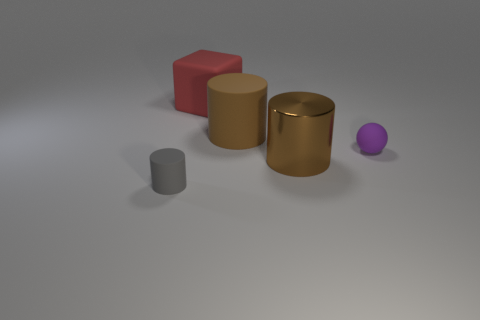What is the purple ball made of?
Provide a succinct answer. Rubber. There is a brown cylinder that is in front of the rubber ball; is it the same size as the brown matte cylinder?
Provide a short and direct response. Yes. Is there any other thing that is the same size as the purple sphere?
Ensure brevity in your answer.  Yes. What is the size of the brown rubber thing that is the same shape as the brown metallic object?
Offer a very short reply. Large. Is the number of big things that are to the right of the large red block the same as the number of small rubber things in front of the big shiny cylinder?
Ensure brevity in your answer.  No. How big is the gray thing in front of the brown matte thing?
Give a very brief answer. Small. Does the large block have the same color as the big metallic object?
Ensure brevity in your answer.  No. Is there any other thing that is the same shape as the purple object?
Provide a succinct answer. No. There is a thing that is the same color as the large shiny cylinder; what is its material?
Your answer should be compact. Rubber. Is the number of large matte objects that are to the right of the large brown rubber thing the same as the number of small cyan blocks?
Your response must be concise. Yes. 